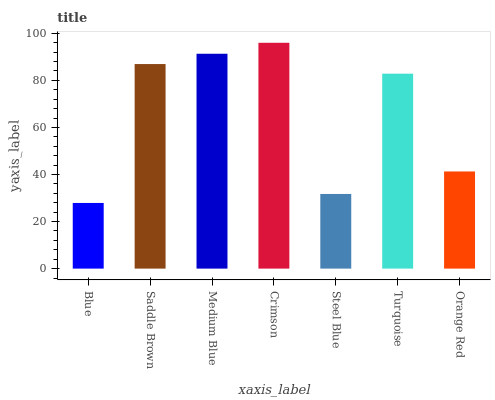Is Blue the minimum?
Answer yes or no. Yes. Is Crimson the maximum?
Answer yes or no. Yes. Is Saddle Brown the minimum?
Answer yes or no. No. Is Saddle Brown the maximum?
Answer yes or no. No. Is Saddle Brown greater than Blue?
Answer yes or no. Yes. Is Blue less than Saddle Brown?
Answer yes or no. Yes. Is Blue greater than Saddle Brown?
Answer yes or no. No. Is Saddle Brown less than Blue?
Answer yes or no. No. Is Turquoise the high median?
Answer yes or no. Yes. Is Turquoise the low median?
Answer yes or no. Yes. Is Orange Red the high median?
Answer yes or no. No. Is Crimson the low median?
Answer yes or no. No. 